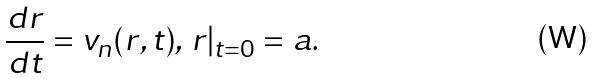<formula> <loc_0><loc_0><loc_500><loc_500>\frac { d r } { d t } = { v } _ { n } ( { r } , t ) , \, { r } | _ { t = 0 } = { a } .</formula> 